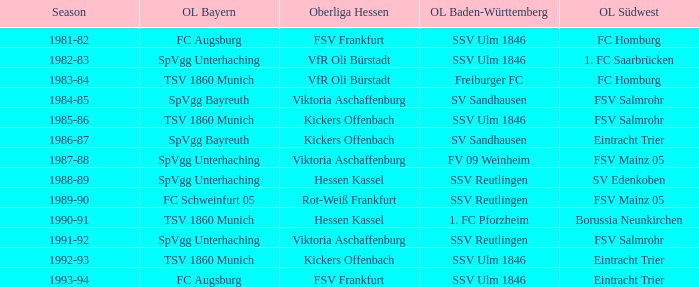Which Season ha spvgg bayreuth and eintracht trier? 1986-87. 